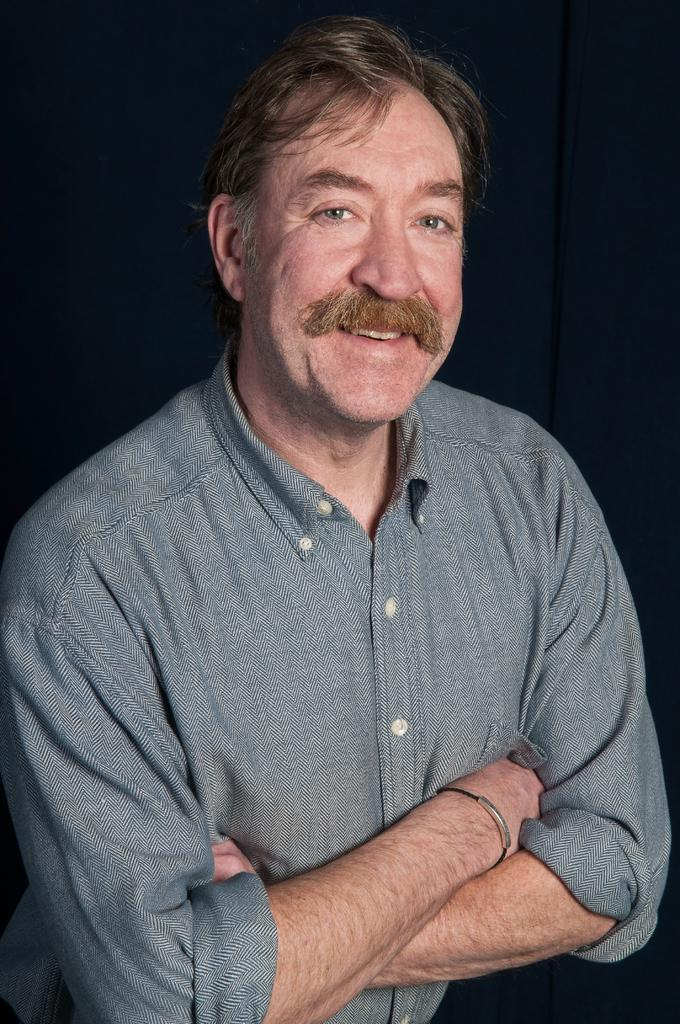Who is the main subject in the image? There is a man in the center of the image. What can be seen in the background of the image? There is a curtain in the background of the image. Are there any fairies visible in the image? No, there are no fairies present in the image. What type of thread is being used to hold up the roof in the image? There is no roof present in the image, so it is not possible to determine what type of thread might be used to hold it up. 